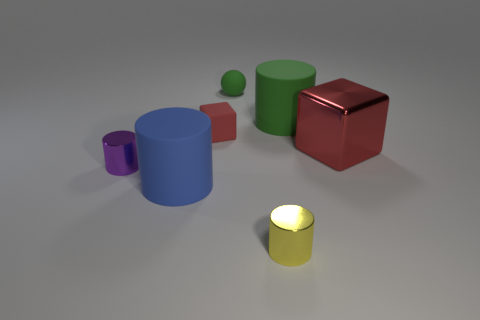The metal thing that is in front of the shiny cylinder on the left side of the large rubber cylinder on the left side of the red rubber thing is what shape?
Your response must be concise. Cylinder. Are there more small blue spheres than tiny red objects?
Provide a short and direct response. No. Are any big rubber objects visible?
Your response must be concise. Yes. How many things are small metal cylinders behind the blue cylinder or small objects on the left side of the red rubber block?
Your response must be concise. 1. Is the color of the large cube the same as the matte ball?
Offer a terse response. No. Is the number of large blue matte cylinders less than the number of red rubber spheres?
Your answer should be very brief. No. There is a tiny purple cylinder; are there any matte cylinders left of it?
Provide a succinct answer. No. Does the sphere have the same material as the big red object?
Keep it short and to the point. No. What color is the other shiny object that is the same shape as the yellow object?
Your response must be concise. Purple. Does the shiny cylinder that is left of the red rubber thing have the same color as the large shiny object?
Provide a succinct answer. No. 